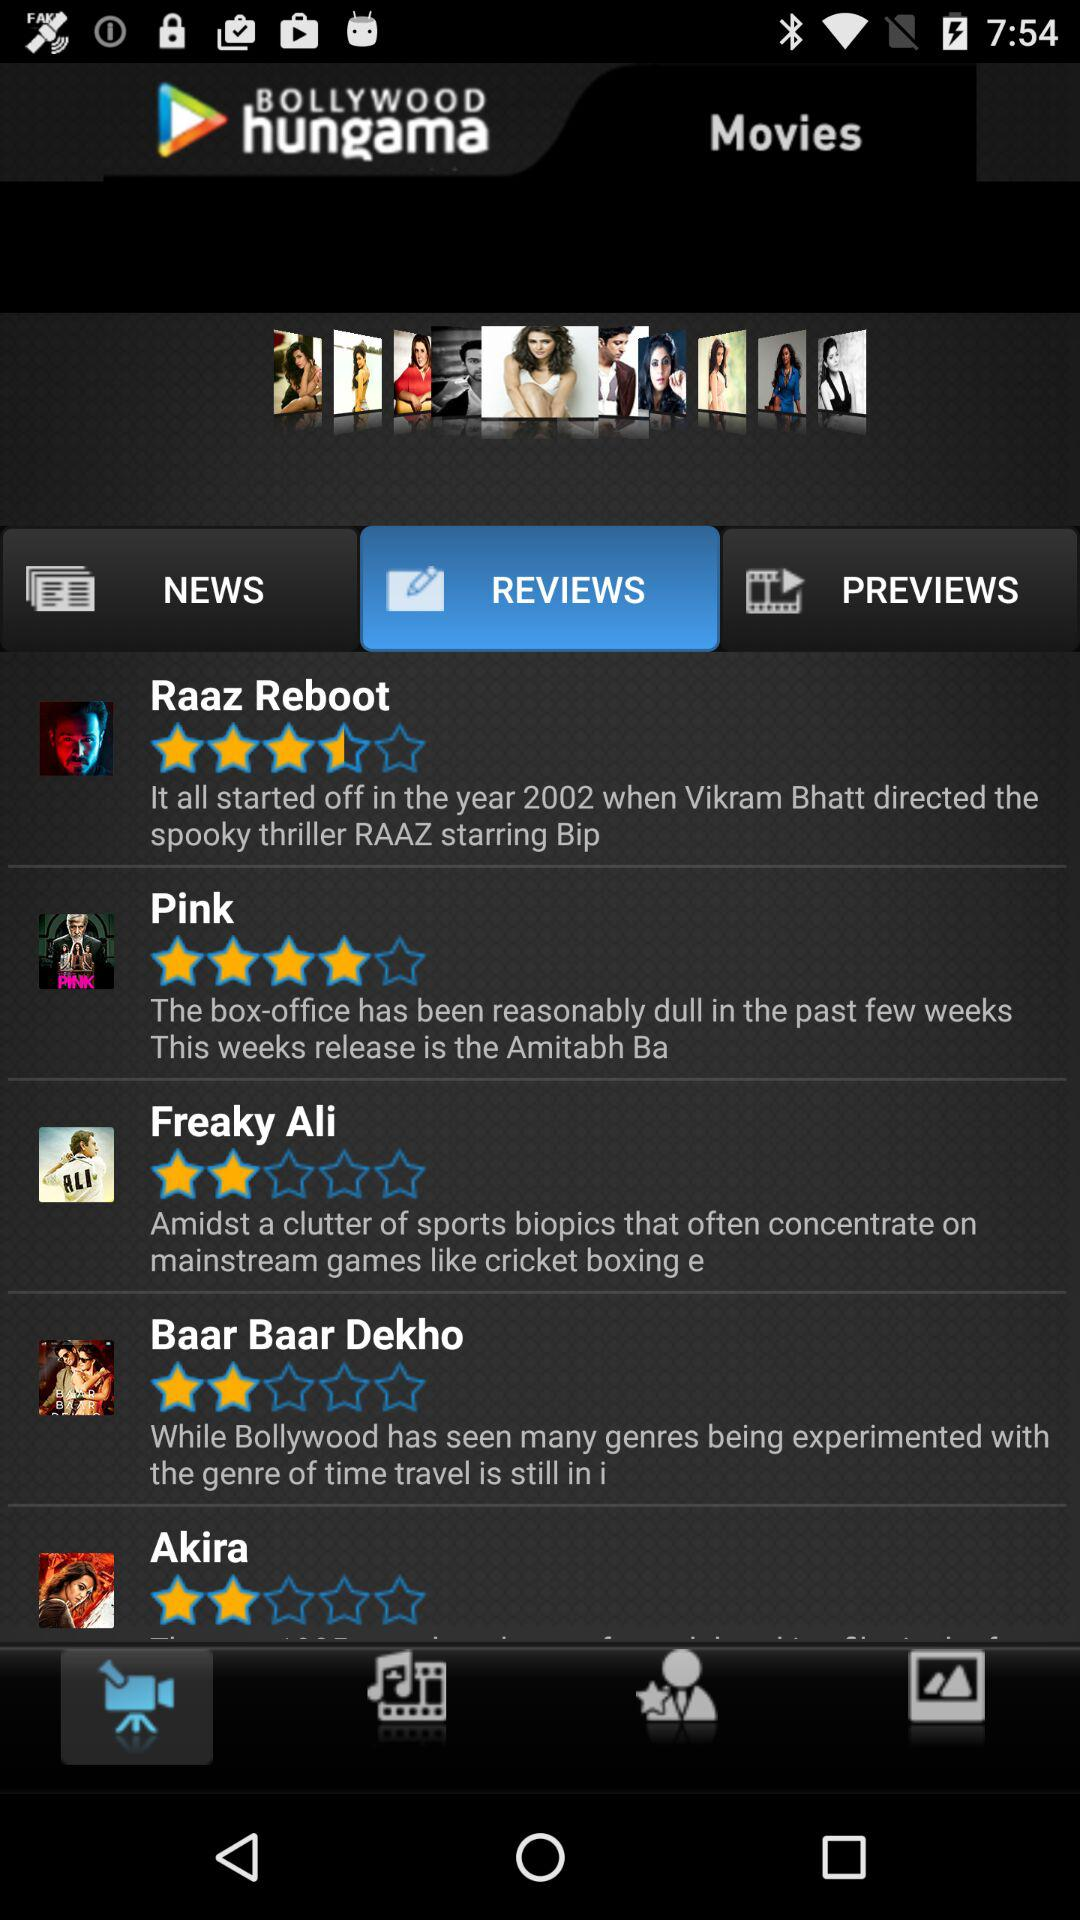What is the rating for "Freaky Ali"? The rating for "Freaky Ali" is 2 stars. 